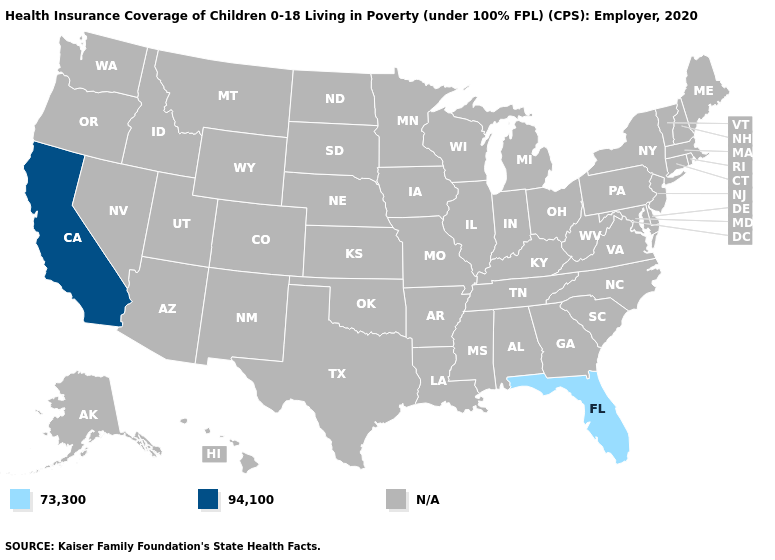How many symbols are there in the legend?
Short answer required. 3. Name the states that have a value in the range 94,100?
Answer briefly. California. Name the states that have a value in the range N/A?
Short answer required. Alabama, Alaska, Arizona, Arkansas, Colorado, Connecticut, Delaware, Georgia, Hawaii, Idaho, Illinois, Indiana, Iowa, Kansas, Kentucky, Louisiana, Maine, Maryland, Massachusetts, Michigan, Minnesota, Mississippi, Missouri, Montana, Nebraska, Nevada, New Hampshire, New Jersey, New Mexico, New York, North Carolina, North Dakota, Ohio, Oklahoma, Oregon, Pennsylvania, Rhode Island, South Carolina, South Dakota, Tennessee, Texas, Utah, Vermont, Virginia, Washington, West Virginia, Wisconsin, Wyoming. Name the states that have a value in the range N/A?
Answer briefly. Alabama, Alaska, Arizona, Arkansas, Colorado, Connecticut, Delaware, Georgia, Hawaii, Idaho, Illinois, Indiana, Iowa, Kansas, Kentucky, Louisiana, Maine, Maryland, Massachusetts, Michigan, Minnesota, Mississippi, Missouri, Montana, Nebraska, Nevada, New Hampshire, New Jersey, New Mexico, New York, North Carolina, North Dakota, Ohio, Oklahoma, Oregon, Pennsylvania, Rhode Island, South Carolina, South Dakota, Tennessee, Texas, Utah, Vermont, Virginia, Washington, West Virginia, Wisconsin, Wyoming. What is the value of Iowa?
Concise answer only. N/A. Name the states that have a value in the range 73,300?
Short answer required. Florida. What is the value of New Mexico?
Quick response, please. N/A. Name the states that have a value in the range 73,300?
Be succinct. Florida. Name the states that have a value in the range 94,100?
Give a very brief answer. California. What is the value of Delaware?
Write a very short answer. N/A. How many symbols are there in the legend?
Concise answer only. 3. 